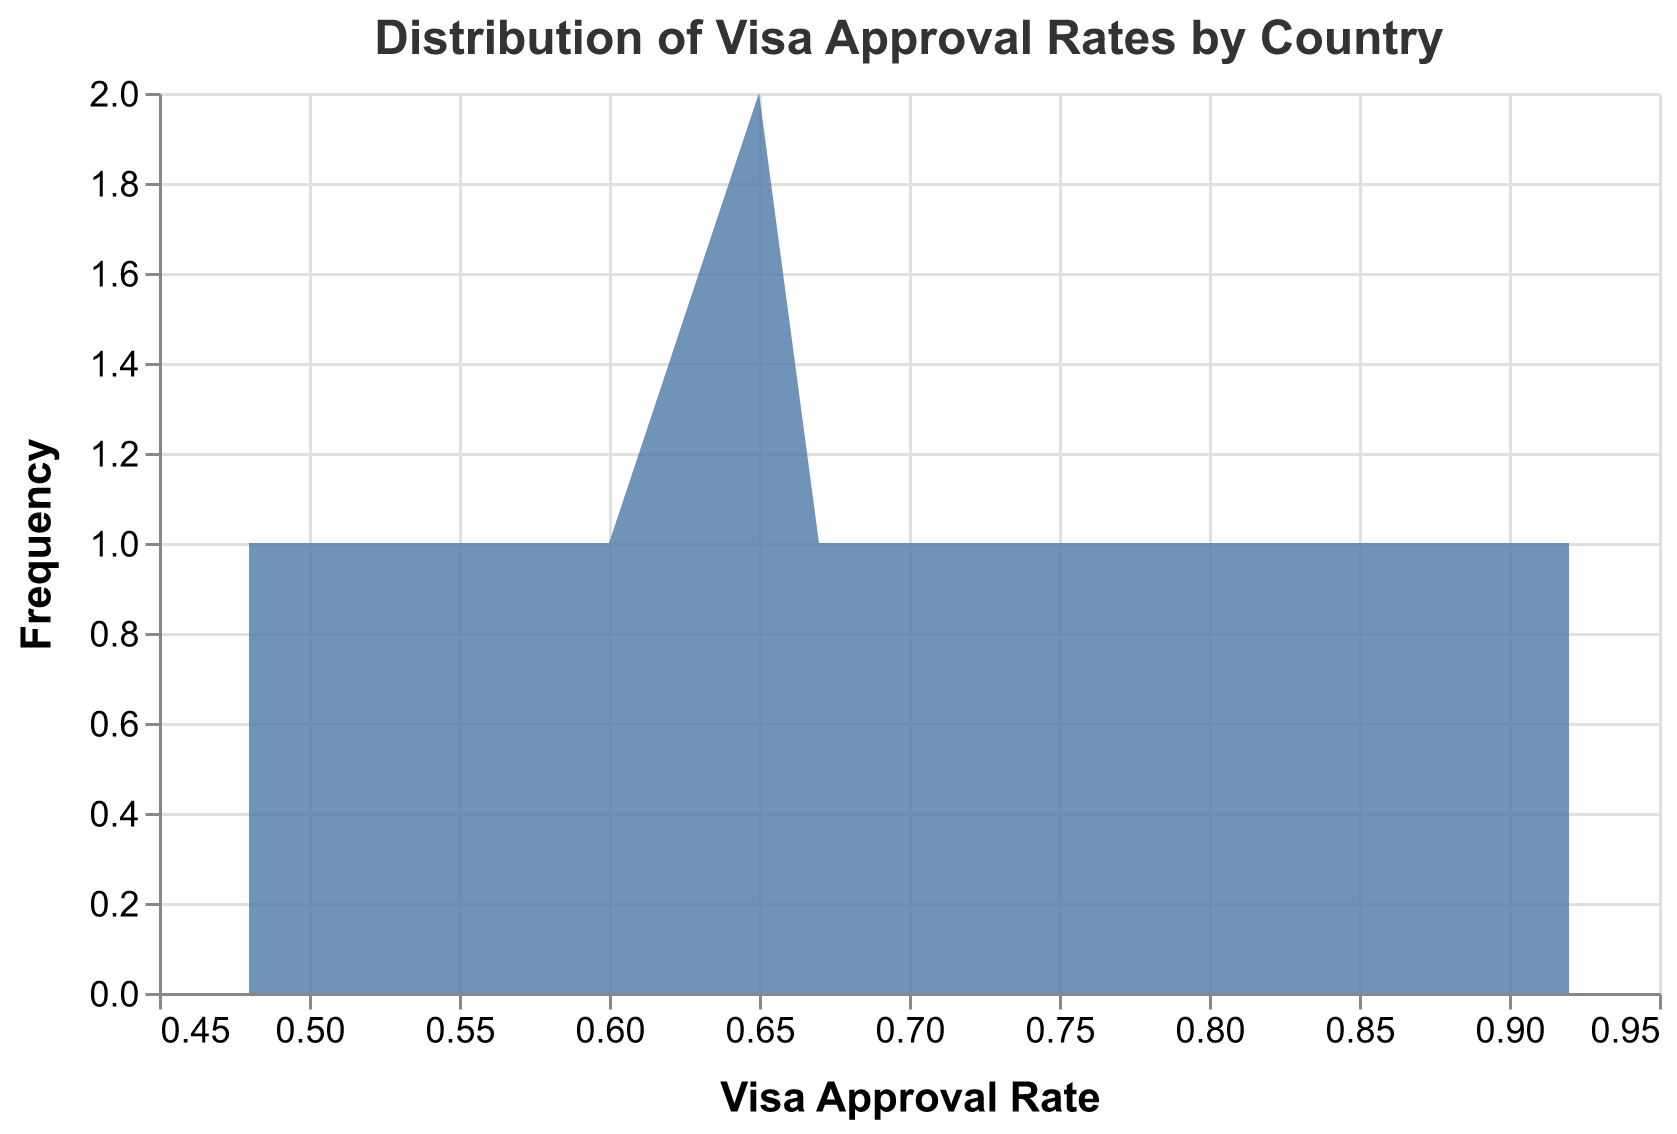What is the title of the plot? The title is displayed at the top of the plot in a large font size, giving an overview of what the plot represents.
Answer: Distribution of Visa Approval Rates by Country What is the range of the x-axis? The x-axis represents the Visa Approval Rate. The minimum value on the x-axis appears to be 0.48, and the maximum value appears to be 0.92.
Answer: 0.48 to 0.92 Which country has the highest frequency of visa approval rates above 0.85? The plot shows the frequencies of visa approval rates across different countries. The country with a high number of approvals above 0.85 can be identified by a notable peak in that range.
Answer: Canada What is the color used for the area in the distplot? The color can be discerned by looking at the filled area representing the frequency of visa approval rates.
Answer: Blue What is the approximate frequency of visa approval rates between 0.70 and 0.80? Observing the plot, we look at the height of the area within the range of 0.70 to 0.80 on the x-axis and approximate the count.
Answer: About 6 Which country has the lowest visa approval rates based on the plot? The lowest visa approval rates can be found by examining the plot segments that are closest to the left side of the x-axis.
Answer: Nigeria Which country has the most consistent visa approval rates? Consistency can be identified by observing which country's visa approval rates have the narrowest spread or the least variability along the x-axis.
Answer: Canada Are there any countries with visa approval rates less than 0.50? To determine this, examine the leftmost part of the plot to see if any segments extend below a visa approval rate of 0.50.
Answer: Yes, Nigeria Which country exhibits the widest spread in visa approval rates? The country with the widest range of visa approval rates can be determined by observing the distribution that stretches the furthest along the x-axis.
Answer: Brazil Do there appear to be any outliers or unusual visa approval rates? Outliers would be represented by isolated peaks or unusually high or low frequencies compared to other areas of the plot.
Answer: No 